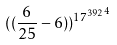<formula> <loc_0><loc_0><loc_500><loc_500>( ( \frac { 6 } { 2 5 } - 6 ) ) ^ { { 1 7 ^ { 3 9 2 } } ^ { 4 } }</formula> 